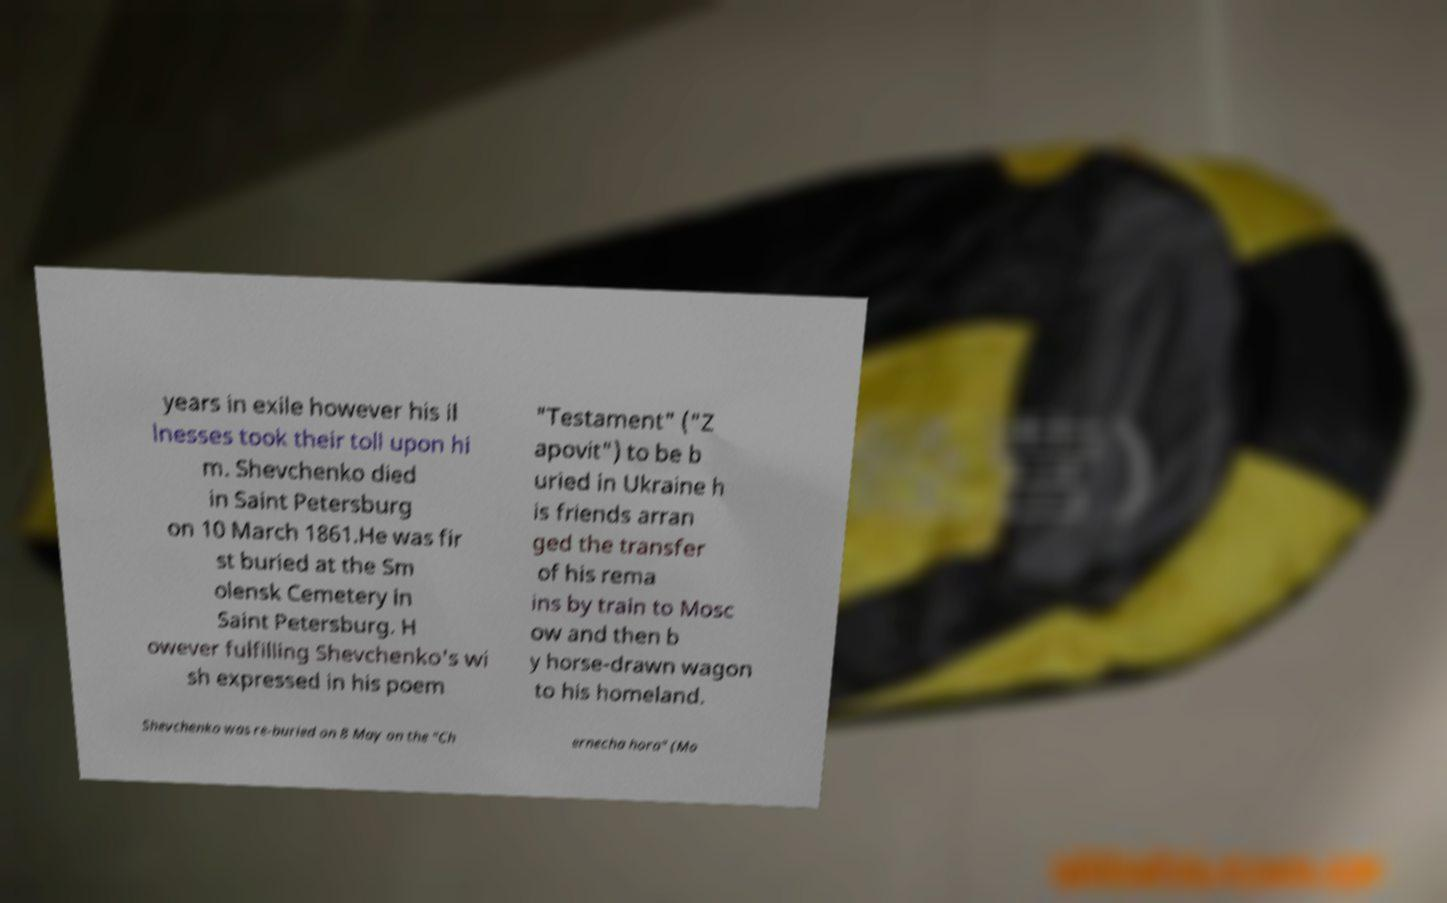Can you read and provide the text displayed in the image?This photo seems to have some interesting text. Can you extract and type it out for me? years in exile however his il lnesses took their toll upon hi m. Shevchenko died in Saint Petersburg on 10 March 1861.He was fir st buried at the Sm olensk Cemetery in Saint Petersburg. H owever fulfilling Shevchenko's wi sh expressed in his poem "Testament" ("Z apovit") to be b uried in Ukraine h is friends arran ged the transfer of his rema ins by train to Mosc ow and then b y horse-drawn wagon to his homeland. Shevchenko was re-buried on 8 May on the "Ch ernecha hora" (Mo 